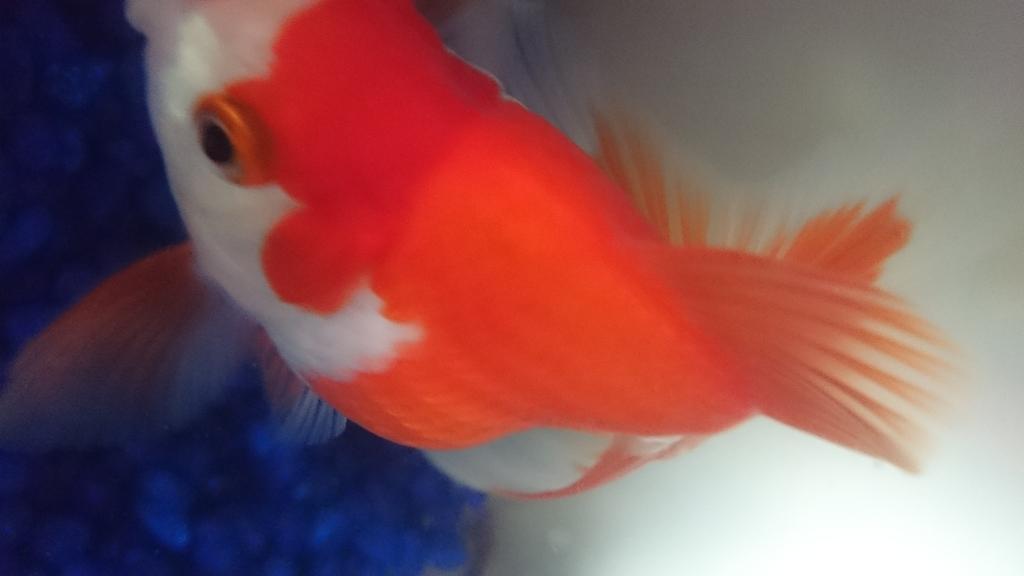Please provide a concise description of this image. In this image we can see a goldfish. 